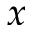<formula> <loc_0><loc_0><loc_500><loc_500>x</formula> 